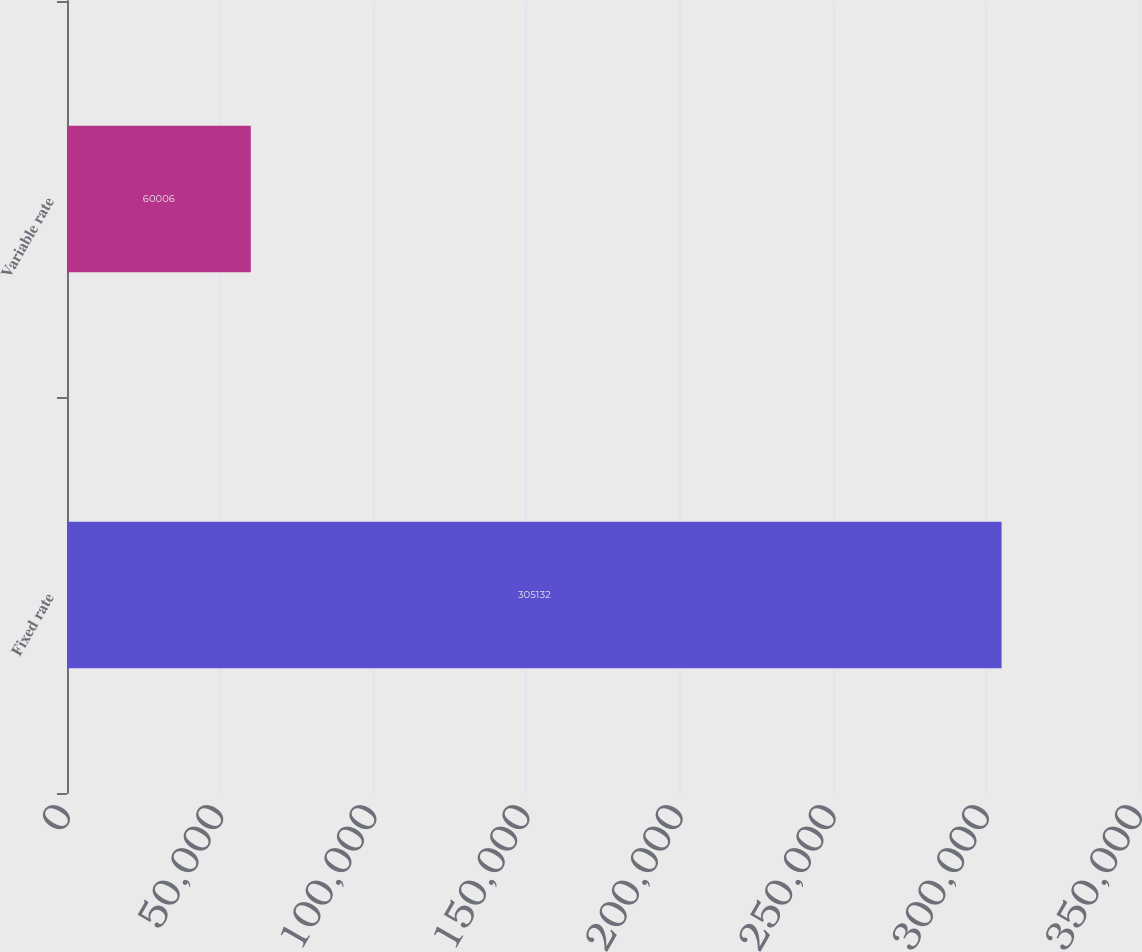<chart> <loc_0><loc_0><loc_500><loc_500><bar_chart><fcel>Fixed rate<fcel>Variable rate<nl><fcel>305132<fcel>60006<nl></chart> 